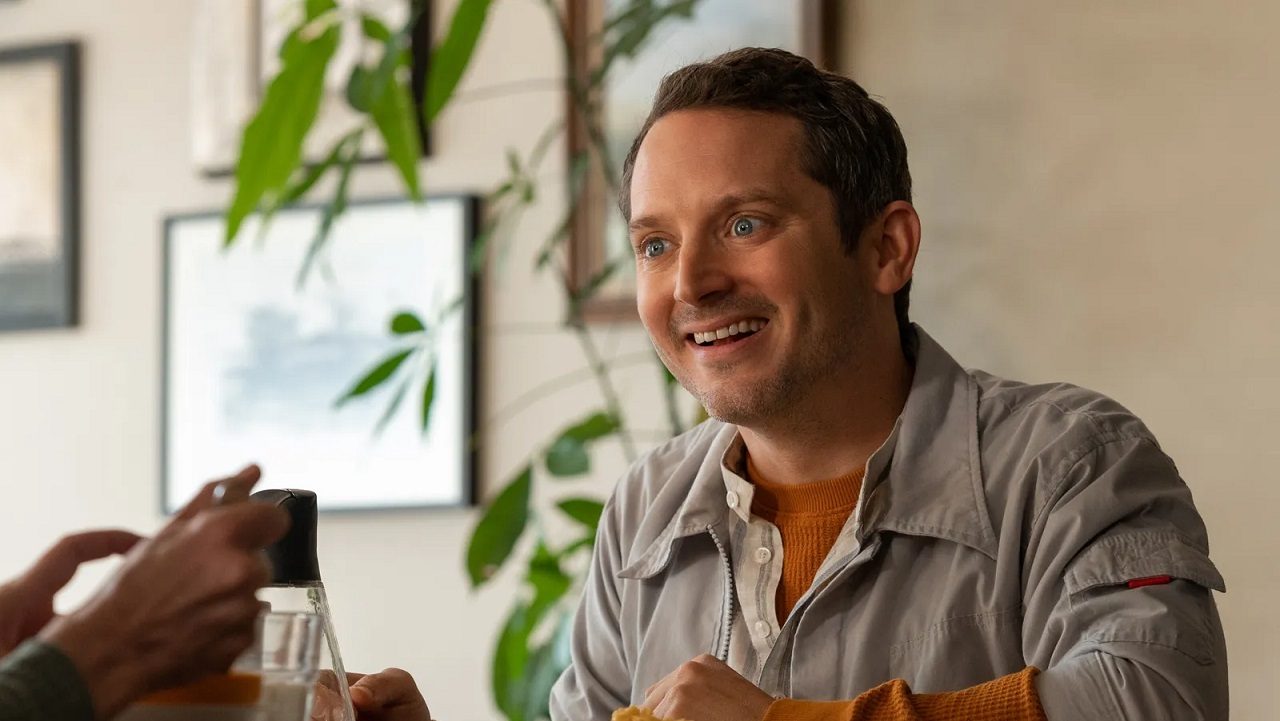If this image were part of a movie scene, what would the plot be like? In a movie, this image might be part of a scene where the main character is enjoying a peaceful moment amidst the chaos of their busy life. The plot could revolve around their journey to find balance and happiness, perhaps in the company of good friends or while pursuing a passion. The scene might show a pivotal moment of realization or connection, contributing to the character’s overall growth and development. 